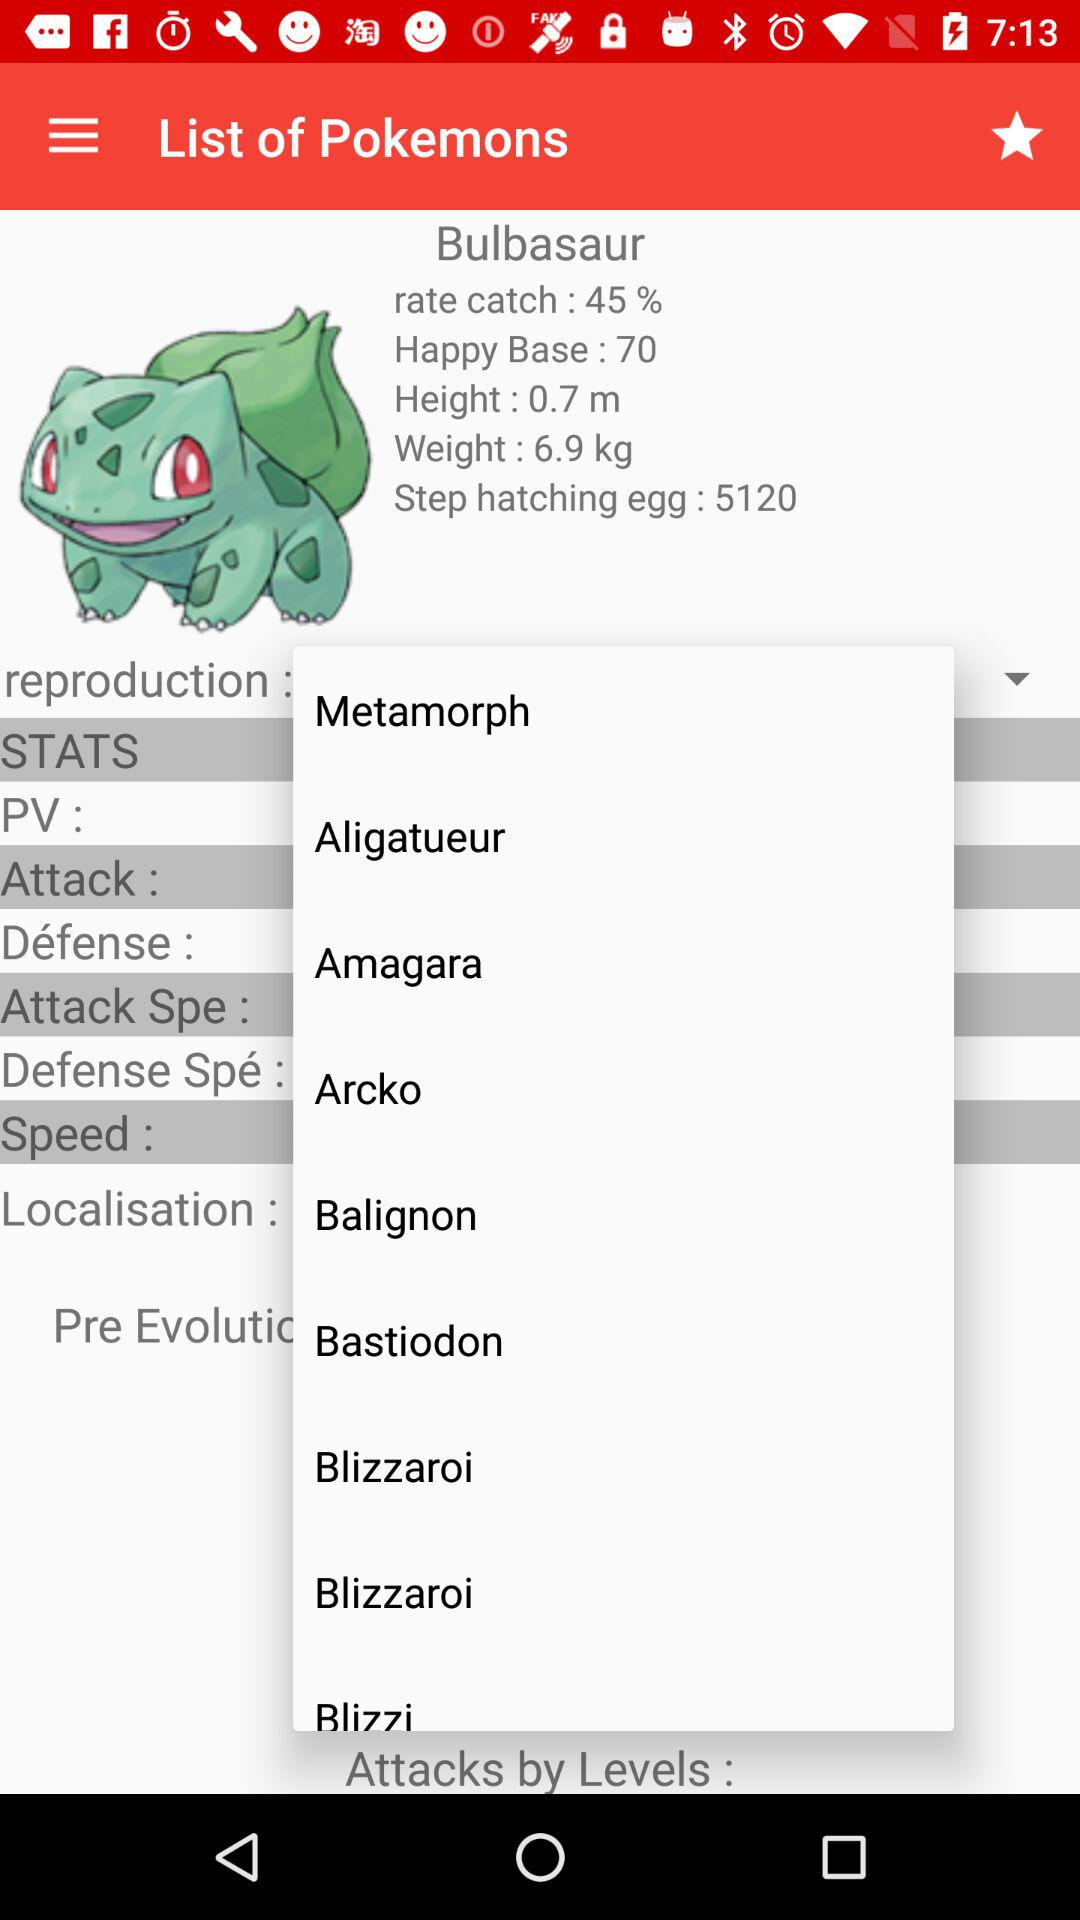What is the count of "Step hatching egg"? The count is 5120. 